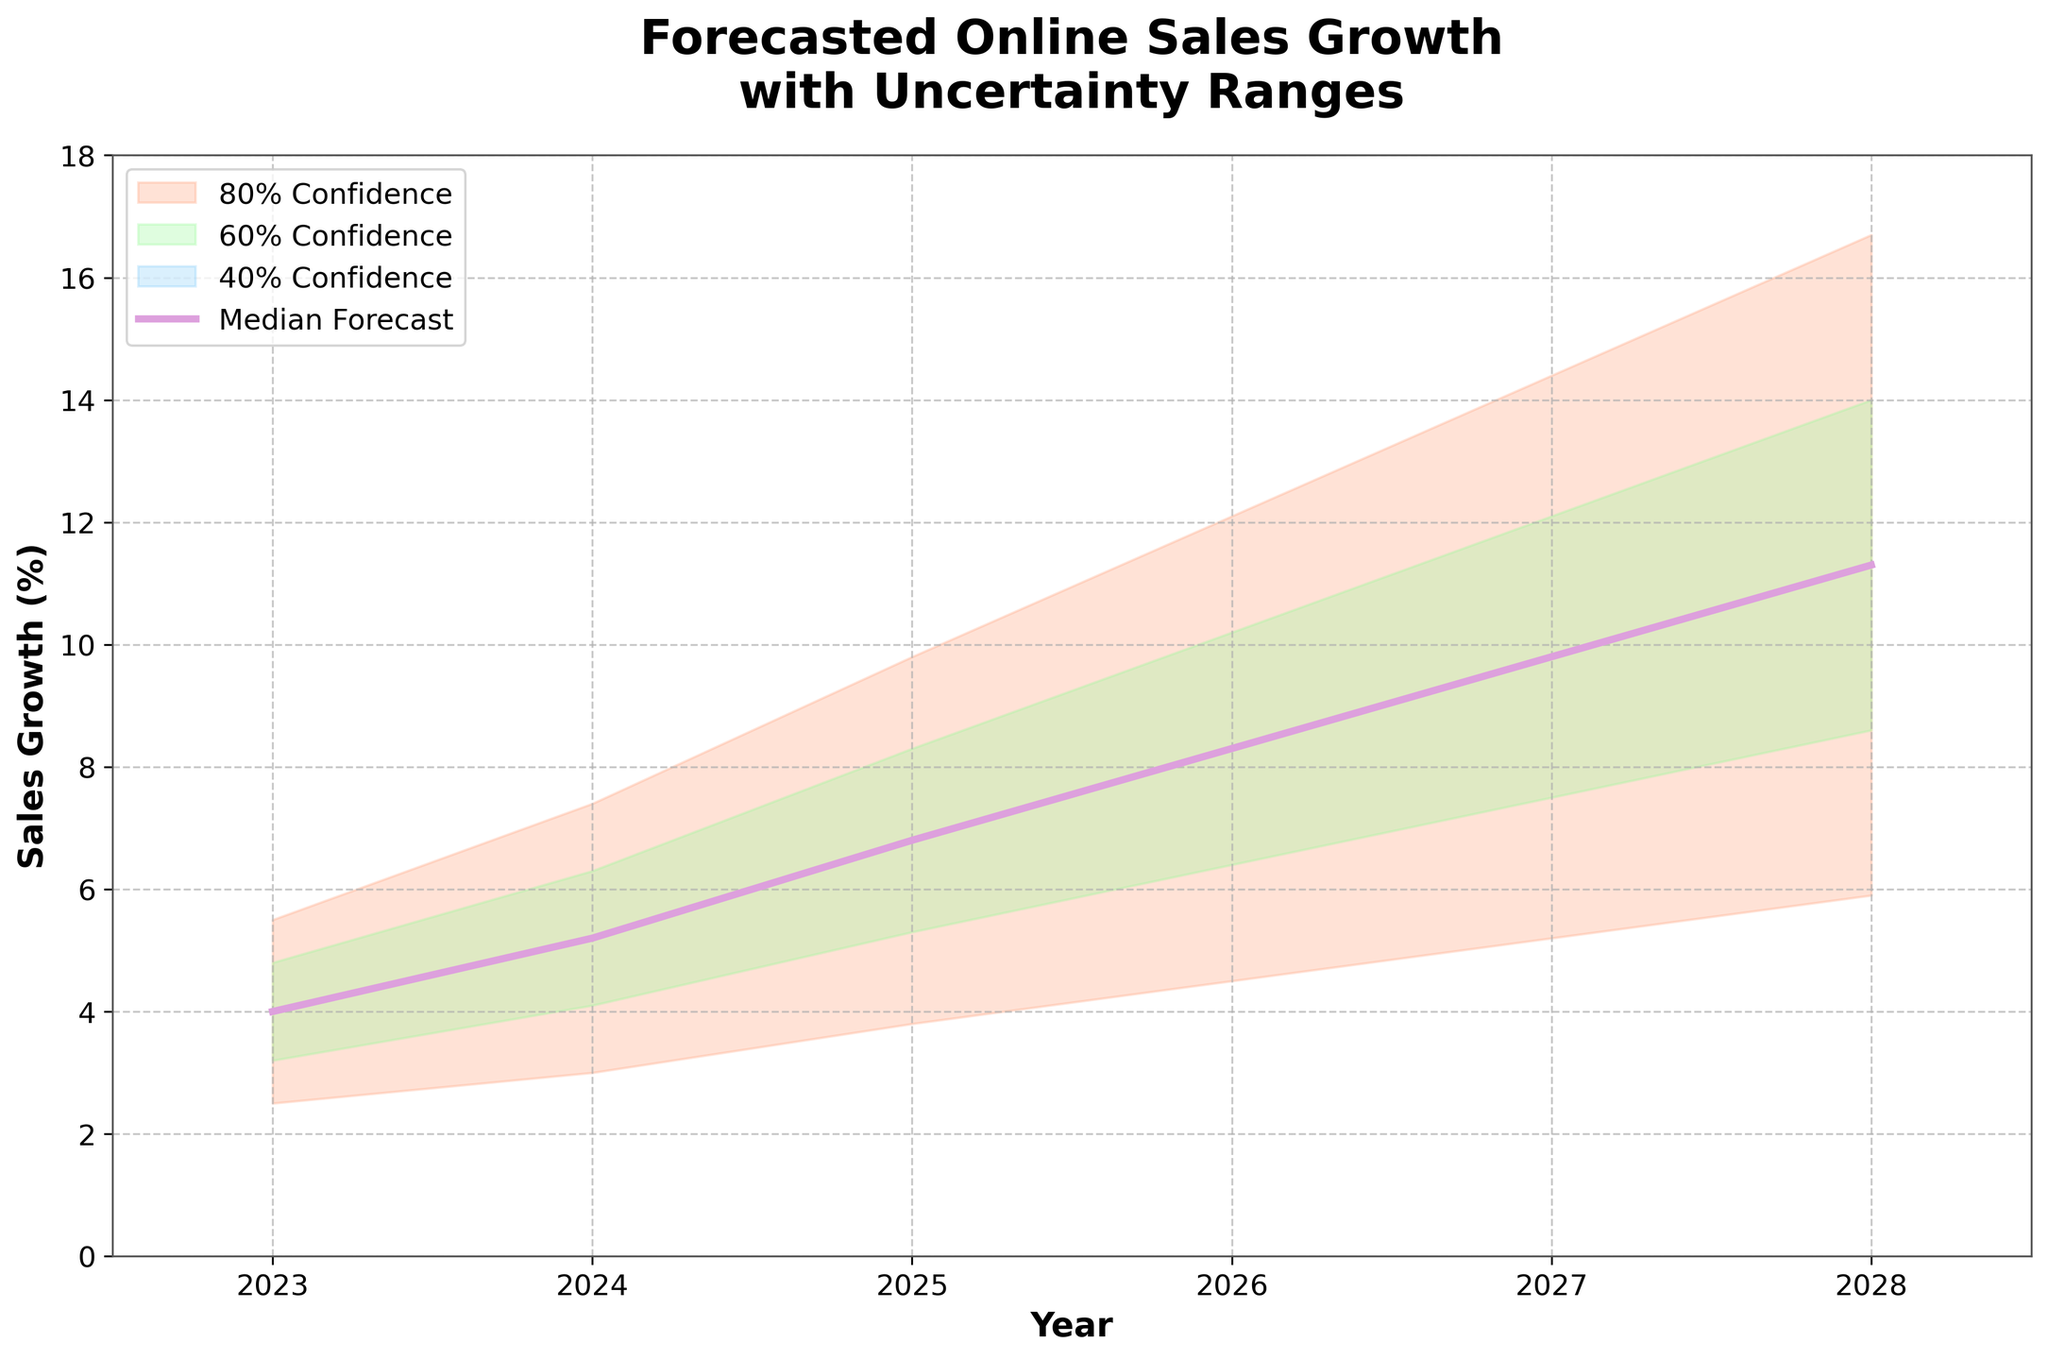What's the title of the chart? The title is written at the top of the chart and states the main subject it represents.
Answer: Forecasted Online Sales Growth with Uncertainty Ranges What are the years covered in the forecast? The x-axis shows the years included in the forecast range, labeled clearly for each year.
Answer: 2023 to 2028 What's the highest predicted sales growth for the year 2027? The highest value on the upper boundary line for the year 2027 represents the maximum predicted growth for that year.
Answer: 14.4% What is the median forecasted sales growth for 2023 and 2025? The median values for each year are represented by the central line, so you would look at the values corresponding to 2023 and 2025.
Answer: 4.0% and 6.8% How does the median forecasted growth change from 2024 to 2026? Subtract the median value for 2024 from the median value for 2026 to find the change.
Answer: 8.3% - 5.2% = 3.1% Which year has the largest range between the low and high forecasted growth? The range can be calculated by subtracting the low forecast value from the high forecast value for each year, and then identifying the maximum difference.
Answer: 2026 Do confidence levels indicate increasing or decreasing uncertainty over time? Observing the width of the shaded regions representing confidence levels, a wider span indicates more uncertainty. Check whether these regions get wider or narrower over the years.
Answer: Increasing uncertainty What's the difference between the highest and lowest forecasted growth in 2028? Subtract the lowest value for 2028 from the highest value for the same year to find the difference.
Answer: 16.7% - 5.9% = 10.8% Which color represents the 60% confidence interval? The legend in the chart specifies the color coding for each confidence interval.
Answer: Light green In which year does the median forecast first reach 10% growth? Look for the year on the x-axis where the central line (median forecast) first hits or exceeds the 10% mark.
Answer: 2026 